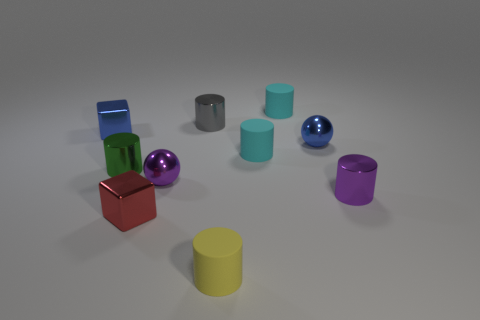Can you describe the arrangement of the objects? The objects are arranged with some spacing on a flat surface. They vary in color and shape, including cubes, cylinders, and spheres, creating an array that looks intentionally placed for display or comparison. 